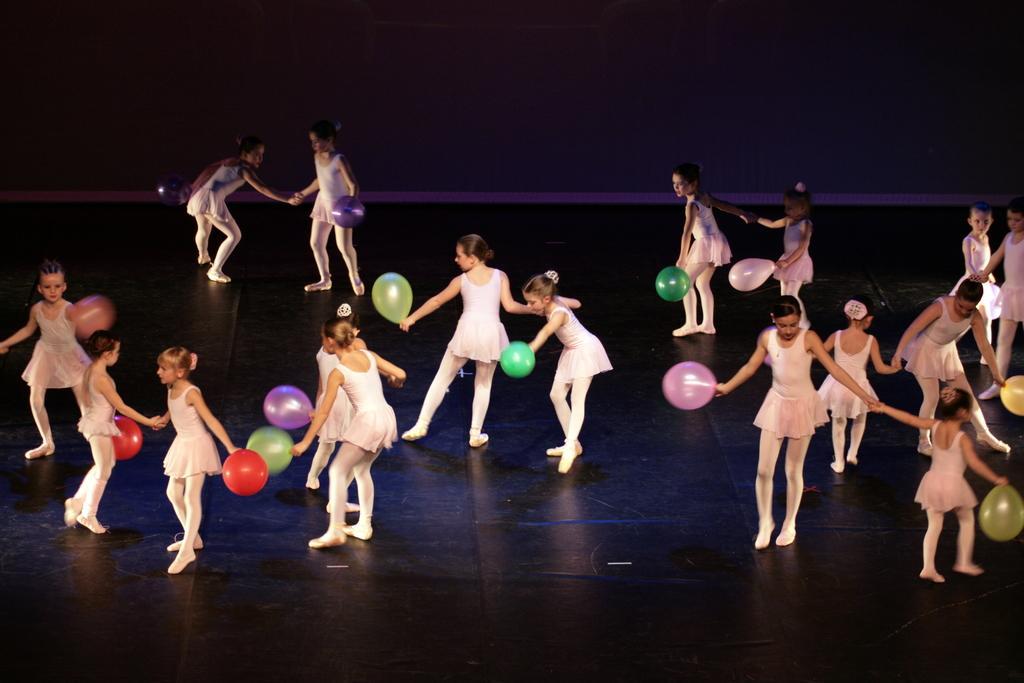How would you summarize this image in a sentence or two? In this image I can see the group of people dancing on the floor. And these people are holding the balloons which are in different colors. In the back I can see the wall. 